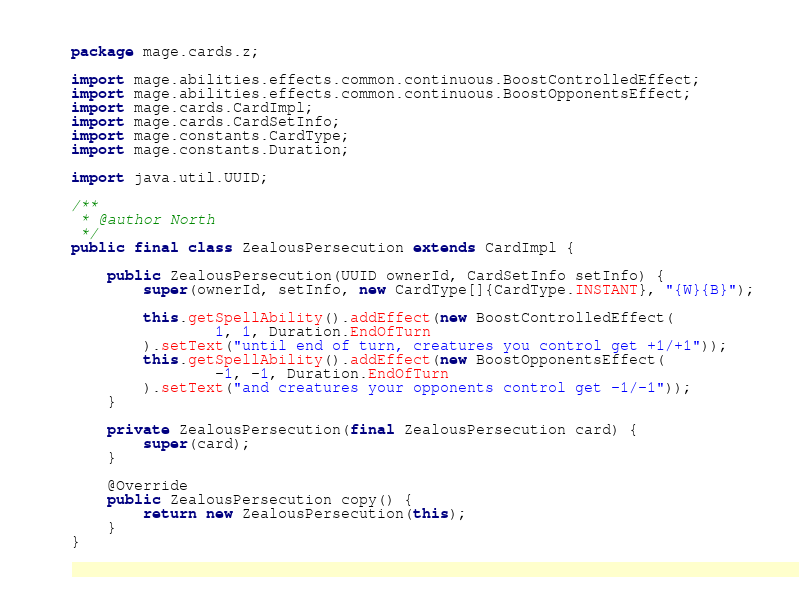Convert code to text. <code><loc_0><loc_0><loc_500><loc_500><_Java_>package mage.cards.z;

import mage.abilities.effects.common.continuous.BoostControlledEffect;
import mage.abilities.effects.common.continuous.BoostOpponentsEffect;
import mage.cards.CardImpl;
import mage.cards.CardSetInfo;
import mage.constants.CardType;
import mage.constants.Duration;

import java.util.UUID;

/**
 * @author North
 */
public final class ZealousPersecution extends CardImpl {

    public ZealousPersecution(UUID ownerId, CardSetInfo setInfo) {
        super(ownerId, setInfo, new CardType[]{CardType.INSTANT}, "{W}{B}");

        this.getSpellAbility().addEffect(new BoostControlledEffect(
                1, 1, Duration.EndOfTurn
        ).setText("until end of turn, creatures you control get +1/+1"));
        this.getSpellAbility().addEffect(new BoostOpponentsEffect(
                -1, -1, Duration.EndOfTurn
        ).setText("and creatures your opponents control get -1/-1"));
    }

    private ZealousPersecution(final ZealousPersecution card) {
        super(card);
    }

    @Override
    public ZealousPersecution copy() {
        return new ZealousPersecution(this);
    }
}
</code> 